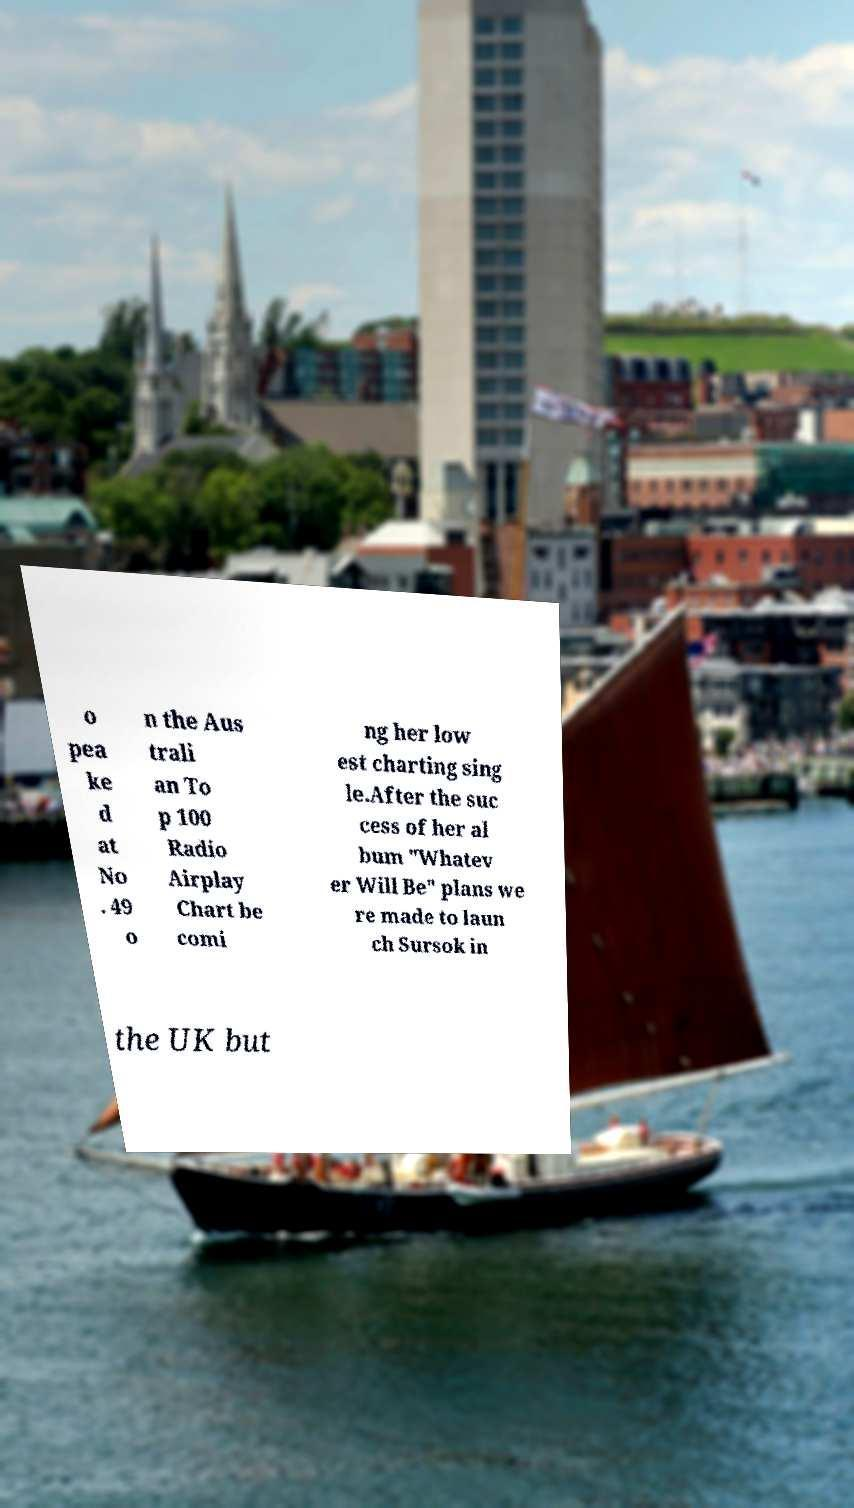There's text embedded in this image that I need extracted. Can you transcribe it verbatim? o pea ke d at No . 49 o n the Aus trali an To p 100 Radio Airplay Chart be comi ng her low est charting sing le.After the suc cess of her al bum "Whatev er Will Be" plans we re made to laun ch Sursok in the UK but 